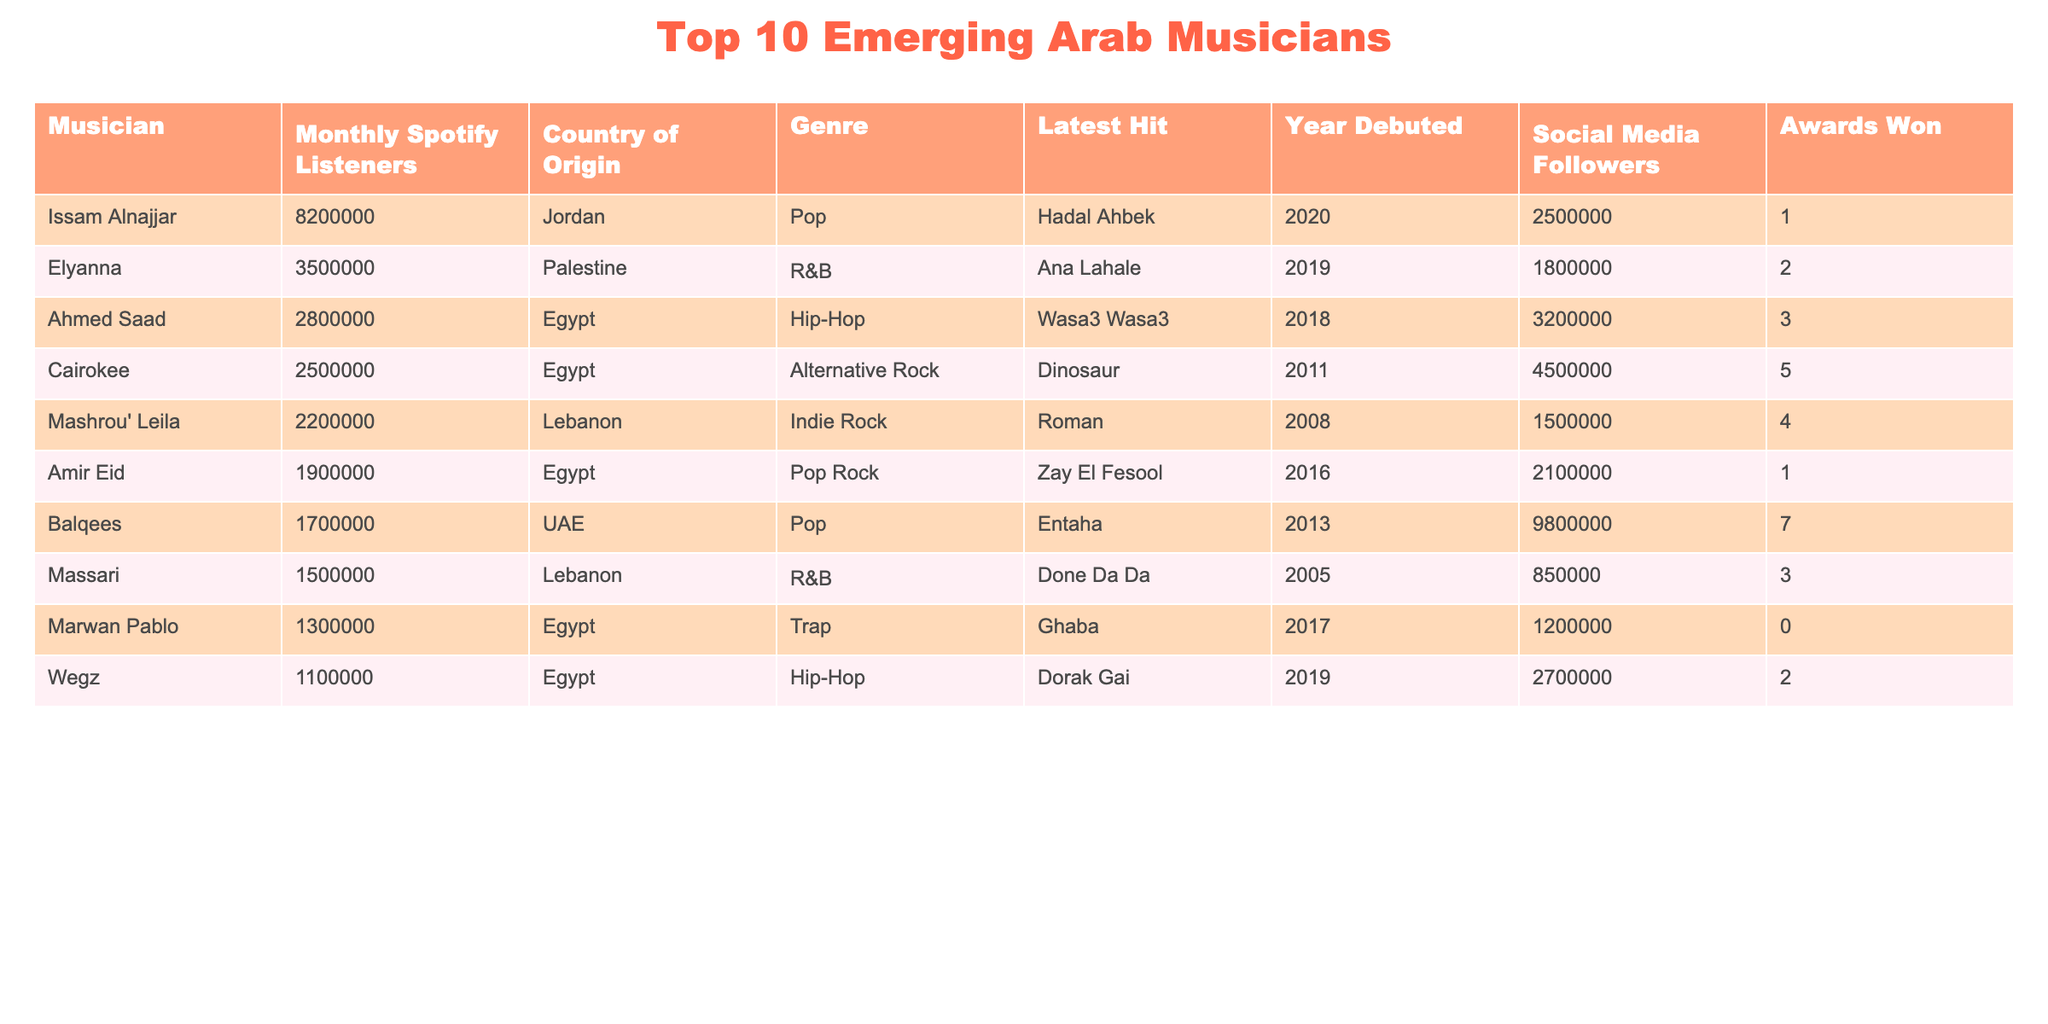What is the musician with the highest monthly Spotify listeners? By looking at the monthly Spotify listeners column, Issam Alnajjar has 8,200,000 listeners, which is the highest compared to the other musicians.
Answer: Issam Alnajjar Which country does Ahmad Saad originate from? Ahmad Saad is listed under the country of origin column as Egypt.
Answer: Egypt What is the latest hit of Massari? The table shows that Massari's latest hit is "Done Da Da."
Answer: Done Da Da How many awards has Elyanna won? Elyanna's row in the table shows that she has won 2 awards.
Answer: 2 What is the total number of Spotify listeners for the top three musicians? Summing the monthly Spotify listeners of the top three musicians: 8,200,000 (Issam Alnajjar) + 3,500,000 (Elyanna) + 2,800,000 (Ahmed Saad) equals 14,500,000.
Answer: 14500000 Is Cairokee from Lebanon? According to the table, Cairokee is listed under Lebanon for their country of origin.
Answer: Yes Which genre does Marwan Pablo belong to? The genre column indicates that Marwan Pablo's genre is Trap.
Answer: Trap What is the average number of social media followers for the top five musicians? The total social media followers for the top five musicians is 25,000,000 (2,500,000 for Issam Alnajjar, 1,800,000 for Elyanna, 3,200,000 for Ahmed Saad, 4,500,000 for Cairokee, and 1,500,000 for Mashrou' Leila). Dividing by five gives an average of 5,000,000.
Answer: 5000000 What is the difference in monthly Spotify listeners between the musician with the highest and lowest listeners? The highest monthly listener count is 8,200,000 (Issam Alnajjar), and the lowest is 1,100,000 (Wegz). The difference is 8,200,000 - 1,100,000 = 7,100,000.
Answer: 7100000 Does Balqees have more social media followers than Wegz? Balqees has 9,800,000 social media followers, while Wegz has 2,700,000. Since 9,800,000 is greater than 2,700,000, the statement is true.
Answer: Yes 